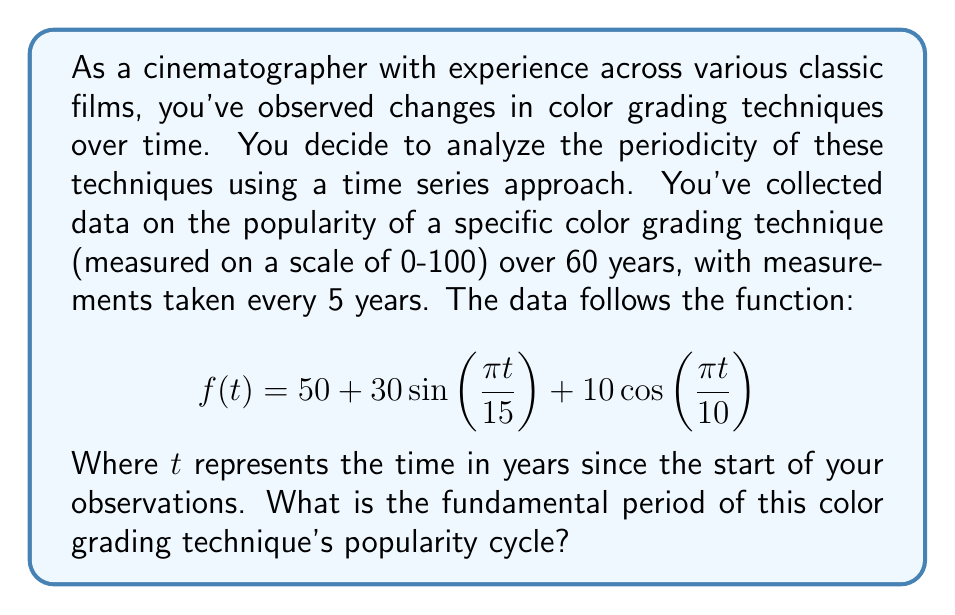Solve this math problem. To find the fundamental period of this time series, we need to analyze the periodic components of the function. The given function is a combination of sine and cosine terms:

$$f(t) = 50 + 30\sin(\frac{\pi t}{15}) + 10\cos(\frac{\pi t}{10})$$

1. First, let's identify the periods of each component:

   a) For the sine term: $30\sin(\frac{\pi t}{15})$
      The period is given by $\frac{2\pi}{\omega}$, where $\omega = \frac{\pi}{15}$
      So, the period is $\frac{2\pi}{\frac{\pi}{15}} = 30$ years

   b) For the cosine term: $10\cos(\frac{\pi t}{10})$
      Similarly, $\omega = \frac{\pi}{10}$
      The period is $\frac{2\pi}{\frac{\pi}{10}} = 20$ years

2. Now that we have the periods of both components (30 years and 20 years), we need to find the least common multiple (LCM) of these periods to determine the fundamental period of the entire function.

3. To find the LCM of 30 and 20:
   - Prime factorization of 30: $2 \times 3 \times 5$
   - Prime factorization of 20: $2^2 \times 5$
   - LCM = $2^2 \times 3 \times 5 = 60$

Therefore, the fundamental period of the color grading technique's popularity cycle is 60 years.
Answer: 60 years 